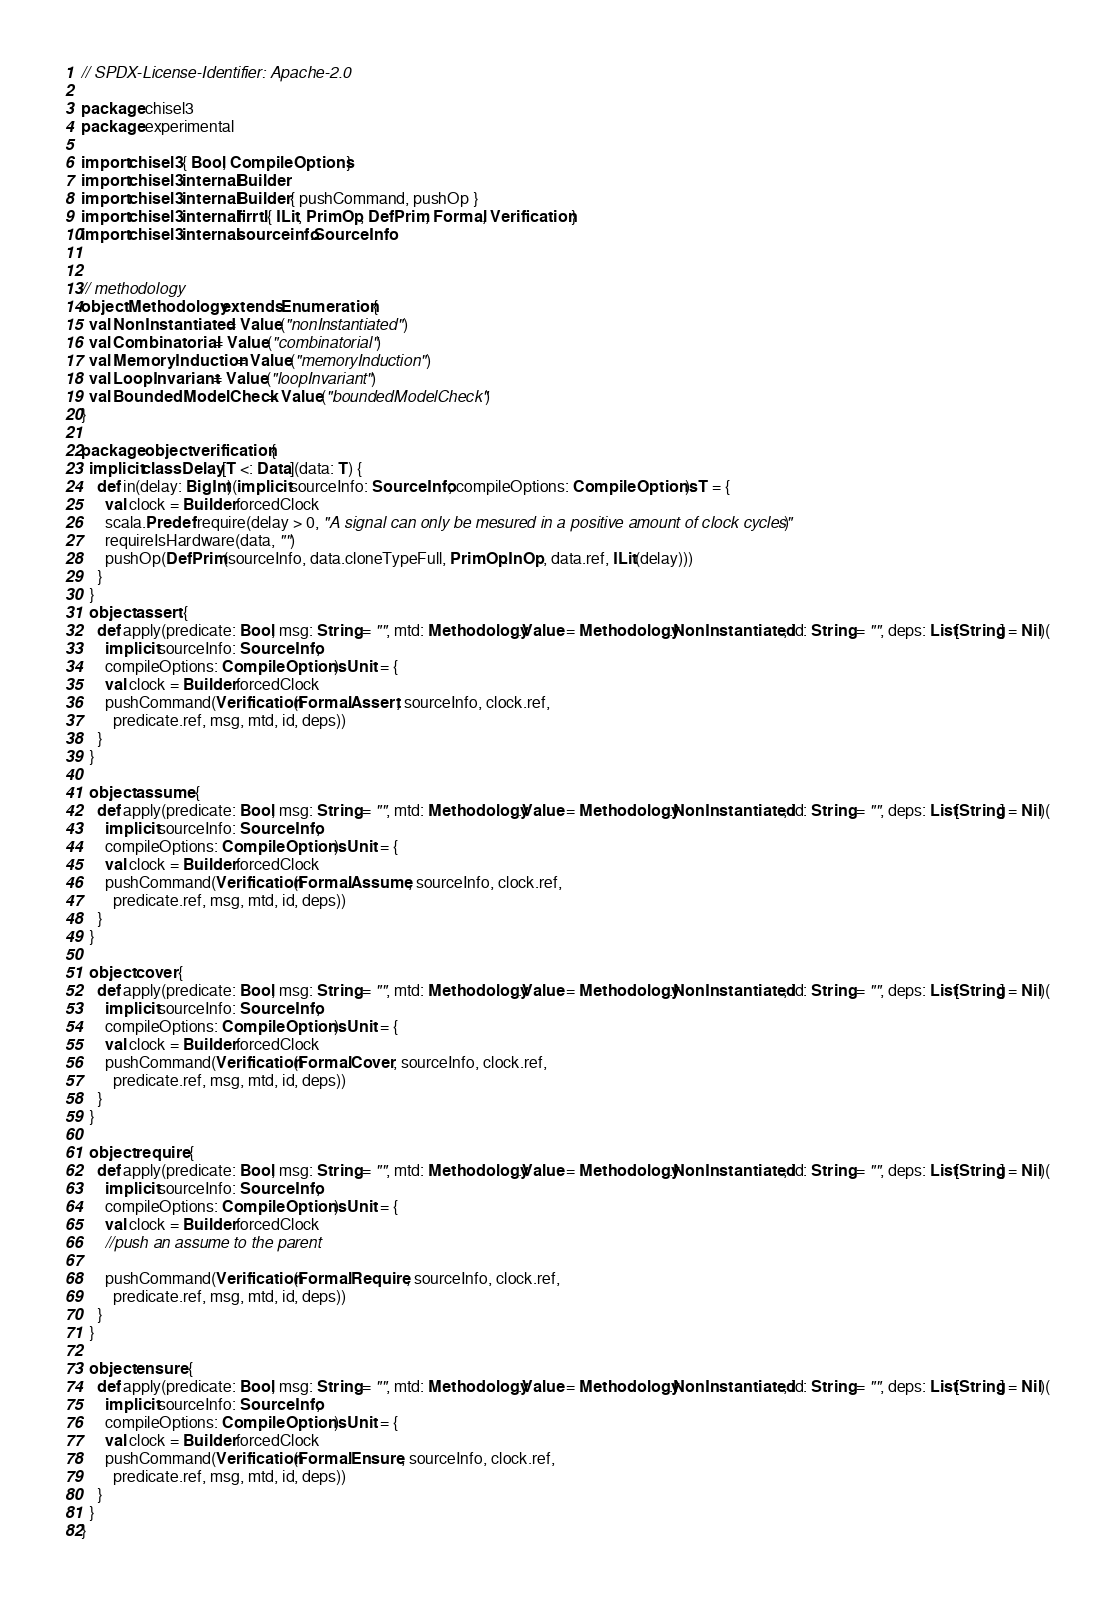Convert code to text. <code><loc_0><loc_0><loc_500><loc_500><_Scala_>// SPDX-License-Identifier: Apache-2.0

package chisel3
package experimental

import chisel3.{ Bool, CompileOptions }
import chisel3.internal.Builder
import chisel3.internal.Builder.{ pushCommand, pushOp }
import chisel3.internal.firrtl.{ ILit, PrimOp, DefPrim, Formal, Verification }
import chisel3.internal.sourceinfo.SourceInfo


// methodology
object Methodology extends Enumeration {
  val NonInstantiated = Value("nonInstantiated")
  val Combinatorial = Value("combinatorial")
  val MemoryInduction = Value("memoryInduction")
  val LoopInvariant = Value("loopInvariant")
  val BoundedModelCheck = Value("boundedModelCheck")
}

package object verification {
  implicit class Delay[T <: Data](data: T) {
    def in(delay: BigInt)(implicit sourceInfo: SourceInfo, compileOptions: CompileOptions): T = {
      val clock = Builder.forcedClock
      scala.Predef.require(delay > 0, "A signal can only be mesured in a positive amount of clock cycles")
      requireIsHardware(data, "")
      pushOp(DefPrim(sourceInfo, data.cloneTypeFull, PrimOp.InOp, data.ref, ILit(delay)))
    }
  }
  object assert {
    def apply(predicate: Bool, msg: String = "", mtd: Methodology.Value = Methodology.NonInstantiated, id: String = "", deps: List[String] = Nil)(
      implicit sourceInfo: SourceInfo,
      compileOptions: CompileOptions): Unit = {
      val clock = Builder.forcedClock
      pushCommand(Verification(Formal.Assert, sourceInfo, clock.ref,
        predicate.ref, msg, mtd, id, deps))
    }
  }

  object assume {
    def apply(predicate: Bool, msg: String = "", mtd: Methodology.Value = Methodology.NonInstantiated, id: String = "", deps: List[String] = Nil)(
      implicit sourceInfo: SourceInfo,
      compileOptions: CompileOptions): Unit = {
      val clock = Builder.forcedClock
      pushCommand(Verification(Formal.Assume, sourceInfo, clock.ref,
        predicate.ref, msg, mtd, id, deps))
    }
  }

  object cover {
    def apply(predicate: Bool, msg: String = "", mtd: Methodology.Value = Methodology.NonInstantiated, id: String = "", deps: List[String] = Nil)(
      implicit sourceInfo: SourceInfo,
      compileOptions: CompileOptions): Unit = {
      val clock = Builder.forcedClock
      pushCommand(Verification(Formal.Cover, sourceInfo, clock.ref,
        predicate.ref, msg, mtd, id, deps))
    }
  }

  object require {
    def apply(predicate: Bool, msg: String = "", mtd: Methodology.Value = Methodology.NonInstantiated, id: String = "", deps: List[String] = Nil)(
      implicit sourceInfo: SourceInfo,
      compileOptions: CompileOptions): Unit = {
      val clock = Builder.forcedClock
      //push an assume to the parent
      
      pushCommand(Verification(Formal.Require, sourceInfo, clock.ref,
        predicate.ref, msg, mtd, id, deps))
    }
  }

  object ensure {
    def apply(predicate: Bool, msg: String = "", mtd: Methodology.Value = Methodology.NonInstantiated, id: String = "", deps: List[String] = Nil)(
      implicit sourceInfo: SourceInfo,
      compileOptions: CompileOptions): Unit = {
      val clock = Builder.forcedClock
      pushCommand(Verification(Formal.Ensure, sourceInfo, clock.ref,
        predicate.ref, msg, mtd, id, deps))
    }
  }
}

</code> 